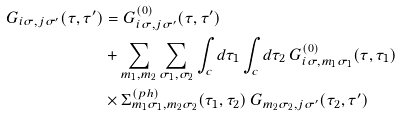<formula> <loc_0><loc_0><loc_500><loc_500>G _ { i \sigma , j \sigma ^ { \prime } } ( \tau , \tau ^ { \prime } ) & = G ^ { ( 0 ) } _ { i \sigma , j \sigma ^ { \prime } } ( \tau , \tau ^ { \prime } ) \\ & + \sum _ { m _ { 1 } , m _ { 2 } } \sum _ { \sigma _ { 1 } , \sigma _ { 2 } } \int _ { c } d \tau _ { 1 } \int _ { c } d \tau _ { 2 } \, G ^ { ( 0 ) } _ { i \sigma , m _ { 1 } \sigma _ { 1 } } ( \tau , \tau _ { 1 } ) \, \\ & \times \Sigma ^ { ( p h ) } _ { m _ { 1 } \sigma _ { 1 } , m _ { 2 } \sigma _ { 2 } } ( \tau _ { 1 } , \tau _ { 2 } ) \, G _ { m _ { 2 } \sigma _ { 2 } , j \sigma ^ { \prime } } ( \tau _ { 2 } , \tau ^ { \prime } )</formula> 